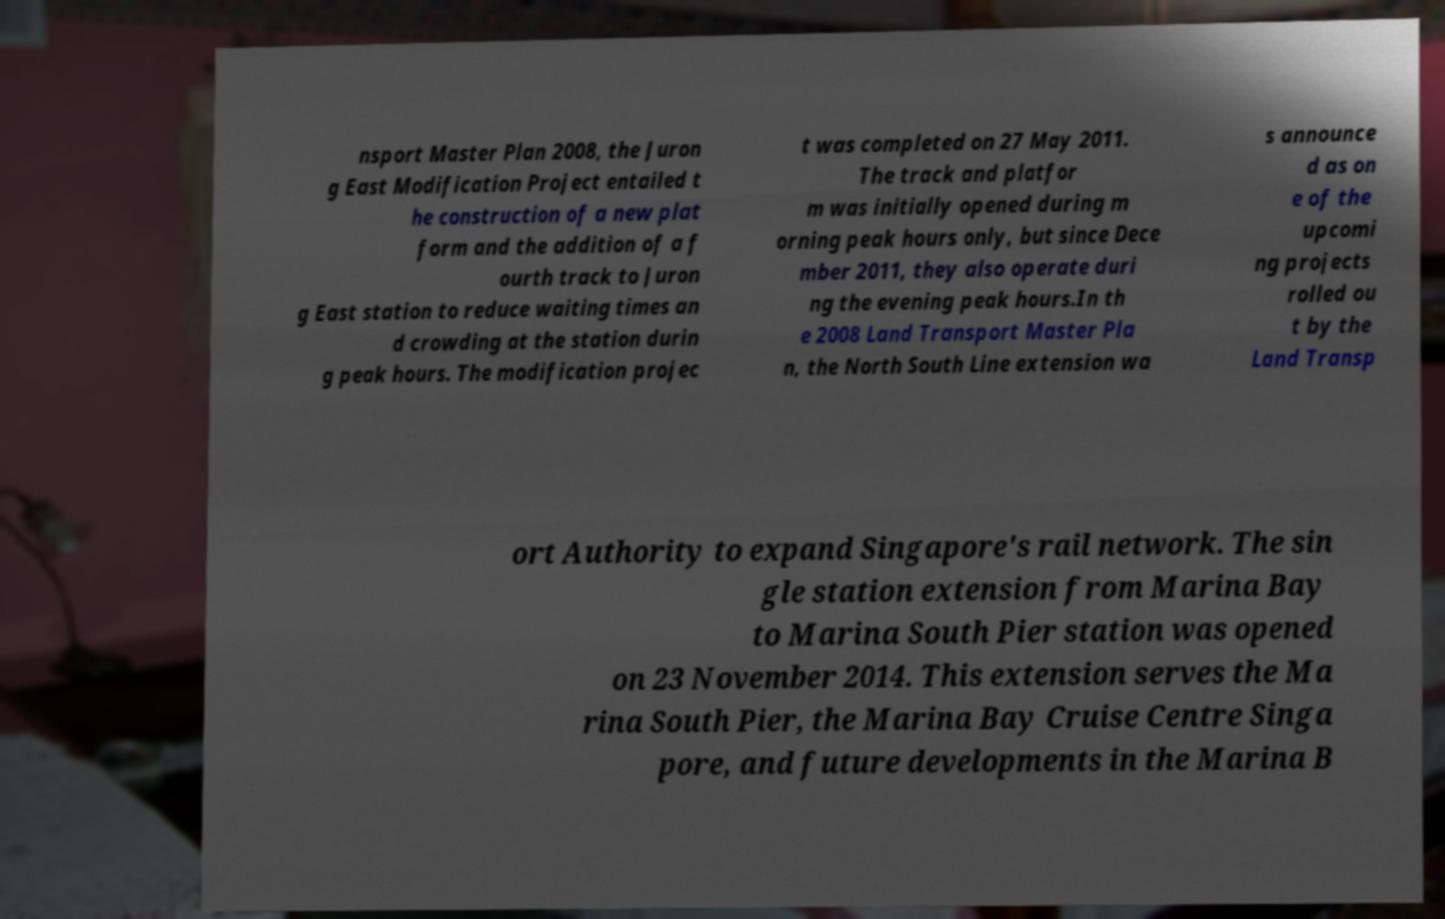Can you read and provide the text displayed in the image?This photo seems to have some interesting text. Can you extract and type it out for me? nsport Master Plan 2008, the Juron g East Modification Project entailed t he construction of a new plat form and the addition of a f ourth track to Juron g East station to reduce waiting times an d crowding at the station durin g peak hours. The modification projec t was completed on 27 May 2011. The track and platfor m was initially opened during m orning peak hours only, but since Dece mber 2011, they also operate duri ng the evening peak hours.In th e 2008 Land Transport Master Pla n, the North South Line extension wa s announce d as on e of the upcomi ng projects rolled ou t by the Land Transp ort Authority to expand Singapore's rail network. The sin gle station extension from Marina Bay to Marina South Pier station was opened on 23 November 2014. This extension serves the Ma rina South Pier, the Marina Bay Cruise Centre Singa pore, and future developments in the Marina B 